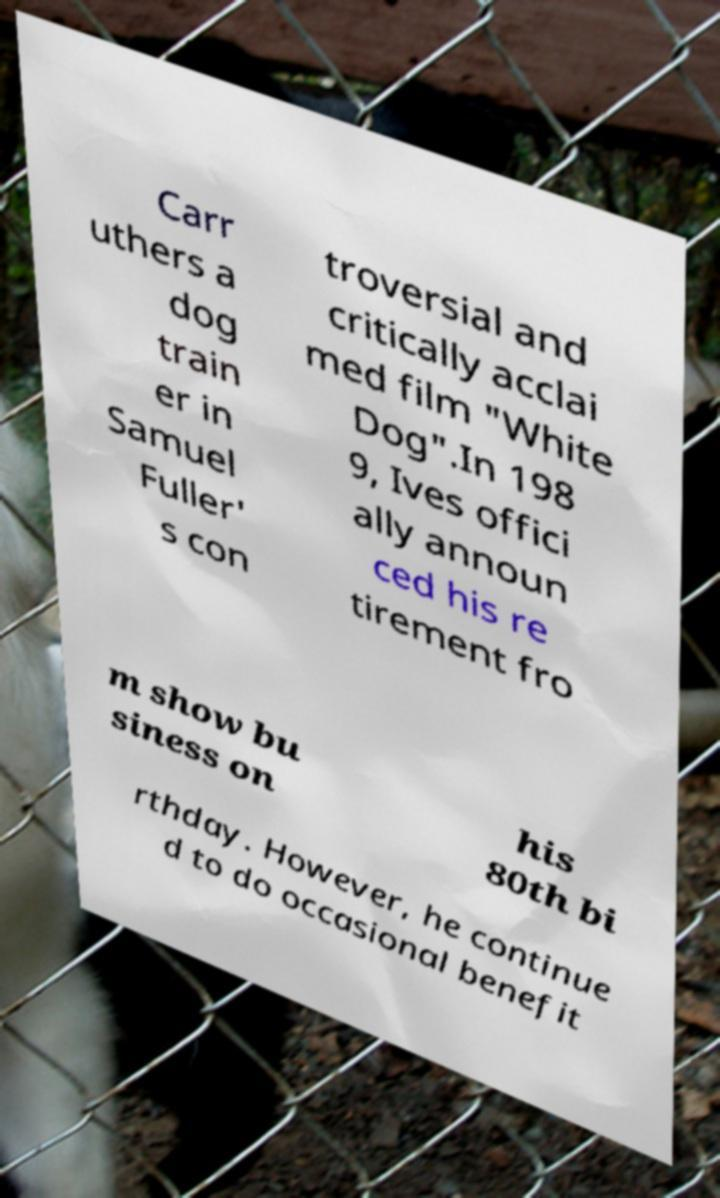For documentation purposes, I need the text within this image transcribed. Could you provide that? Carr uthers a dog train er in Samuel Fuller' s con troversial and critically acclai med film "White Dog".In 198 9, Ives offici ally announ ced his re tirement fro m show bu siness on his 80th bi rthday. However, he continue d to do occasional benefit 